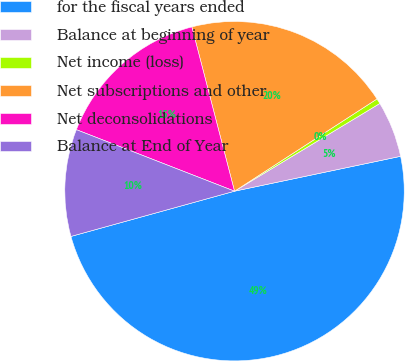Convert chart to OTSL. <chart><loc_0><loc_0><loc_500><loc_500><pie_chart><fcel>for the fiscal years ended<fcel>Balance at beginning of year<fcel>Net income (loss)<fcel>Net subscriptions and other<fcel>Net deconsolidations<fcel>Balance at End of Year<nl><fcel>49.0%<fcel>5.35%<fcel>0.5%<fcel>19.9%<fcel>15.05%<fcel>10.2%<nl></chart> 